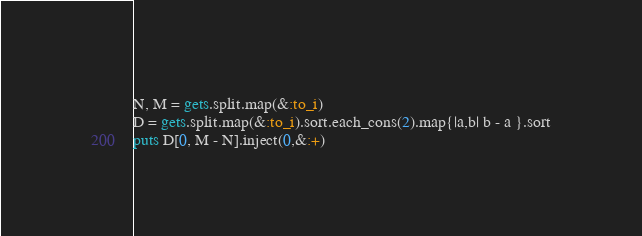<code> <loc_0><loc_0><loc_500><loc_500><_Ruby_>N, M = gets.split.map(&:to_i)
D = gets.split.map(&:to_i).sort.each_cons(2).map{|a,b| b - a }.sort
puts D[0, M - N].inject(0,&:+)
</code> 